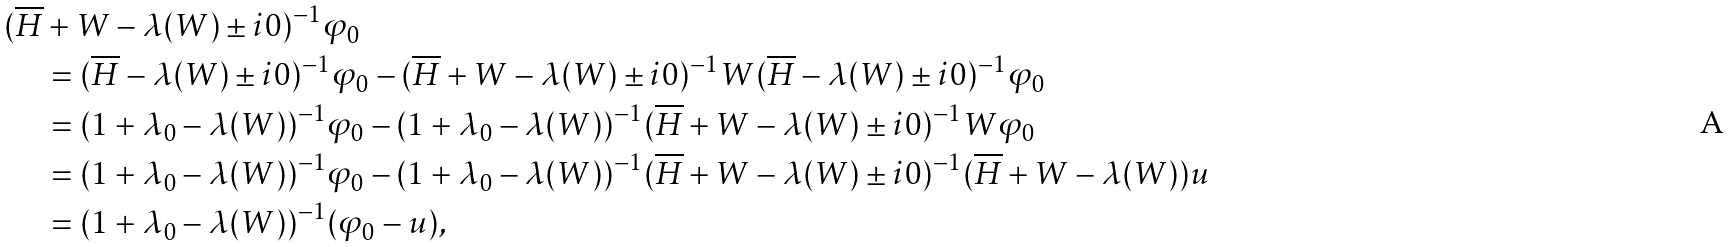<formula> <loc_0><loc_0><loc_500><loc_500>( \overline { H } & + W - \lambda ( W ) \pm i 0 ) ^ { - 1 } \varphi _ { 0 } \\ & = ( \overline { H } - \lambda ( W ) \pm i 0 ) ^ { - 1 } \varphi _ { 0 } - ( \overline { H } + W - \lambda ( W ) \pm i 0 ) ^ { - 1 } W ( \overline { H } - \lambda ( W ) \pm i 0 ) ^ { - 1 } \varphi _ { 0 } \\ & = ( 1 + \lambda _ { 0 } - \lambda ( W ) ) ^ { - 1 } \varphi _ { 0 } - ( 1 + \lambda _ { 0 } - \lambda ( W ) ) ^ { - 1 } ( \overline { H } + W - \lambda ( W ) \pm i 0 ) ^ { - 1 } W \varphi _ { 0 } \\ & = ( 1 + \lambda _ { 0 } - \lambda ( W ) ) ^ { - 1 } \varphi _ { 0 } - ( 1 + \lambda _ { 0 } - \lambda ( W ) ) ^ { - 1 } ( \overline { H } + W - \lambda ( W ) \pm i 0 ) ^ { - 1 } ( \overline { H } + W - \lambda ( W ) ) u \\ & = ( 1 + \lambda _ { 0 } - \lambda ( W ) ) ^ { - 1 } ( \varphi _ { 0 } - u ) ,</formula> 